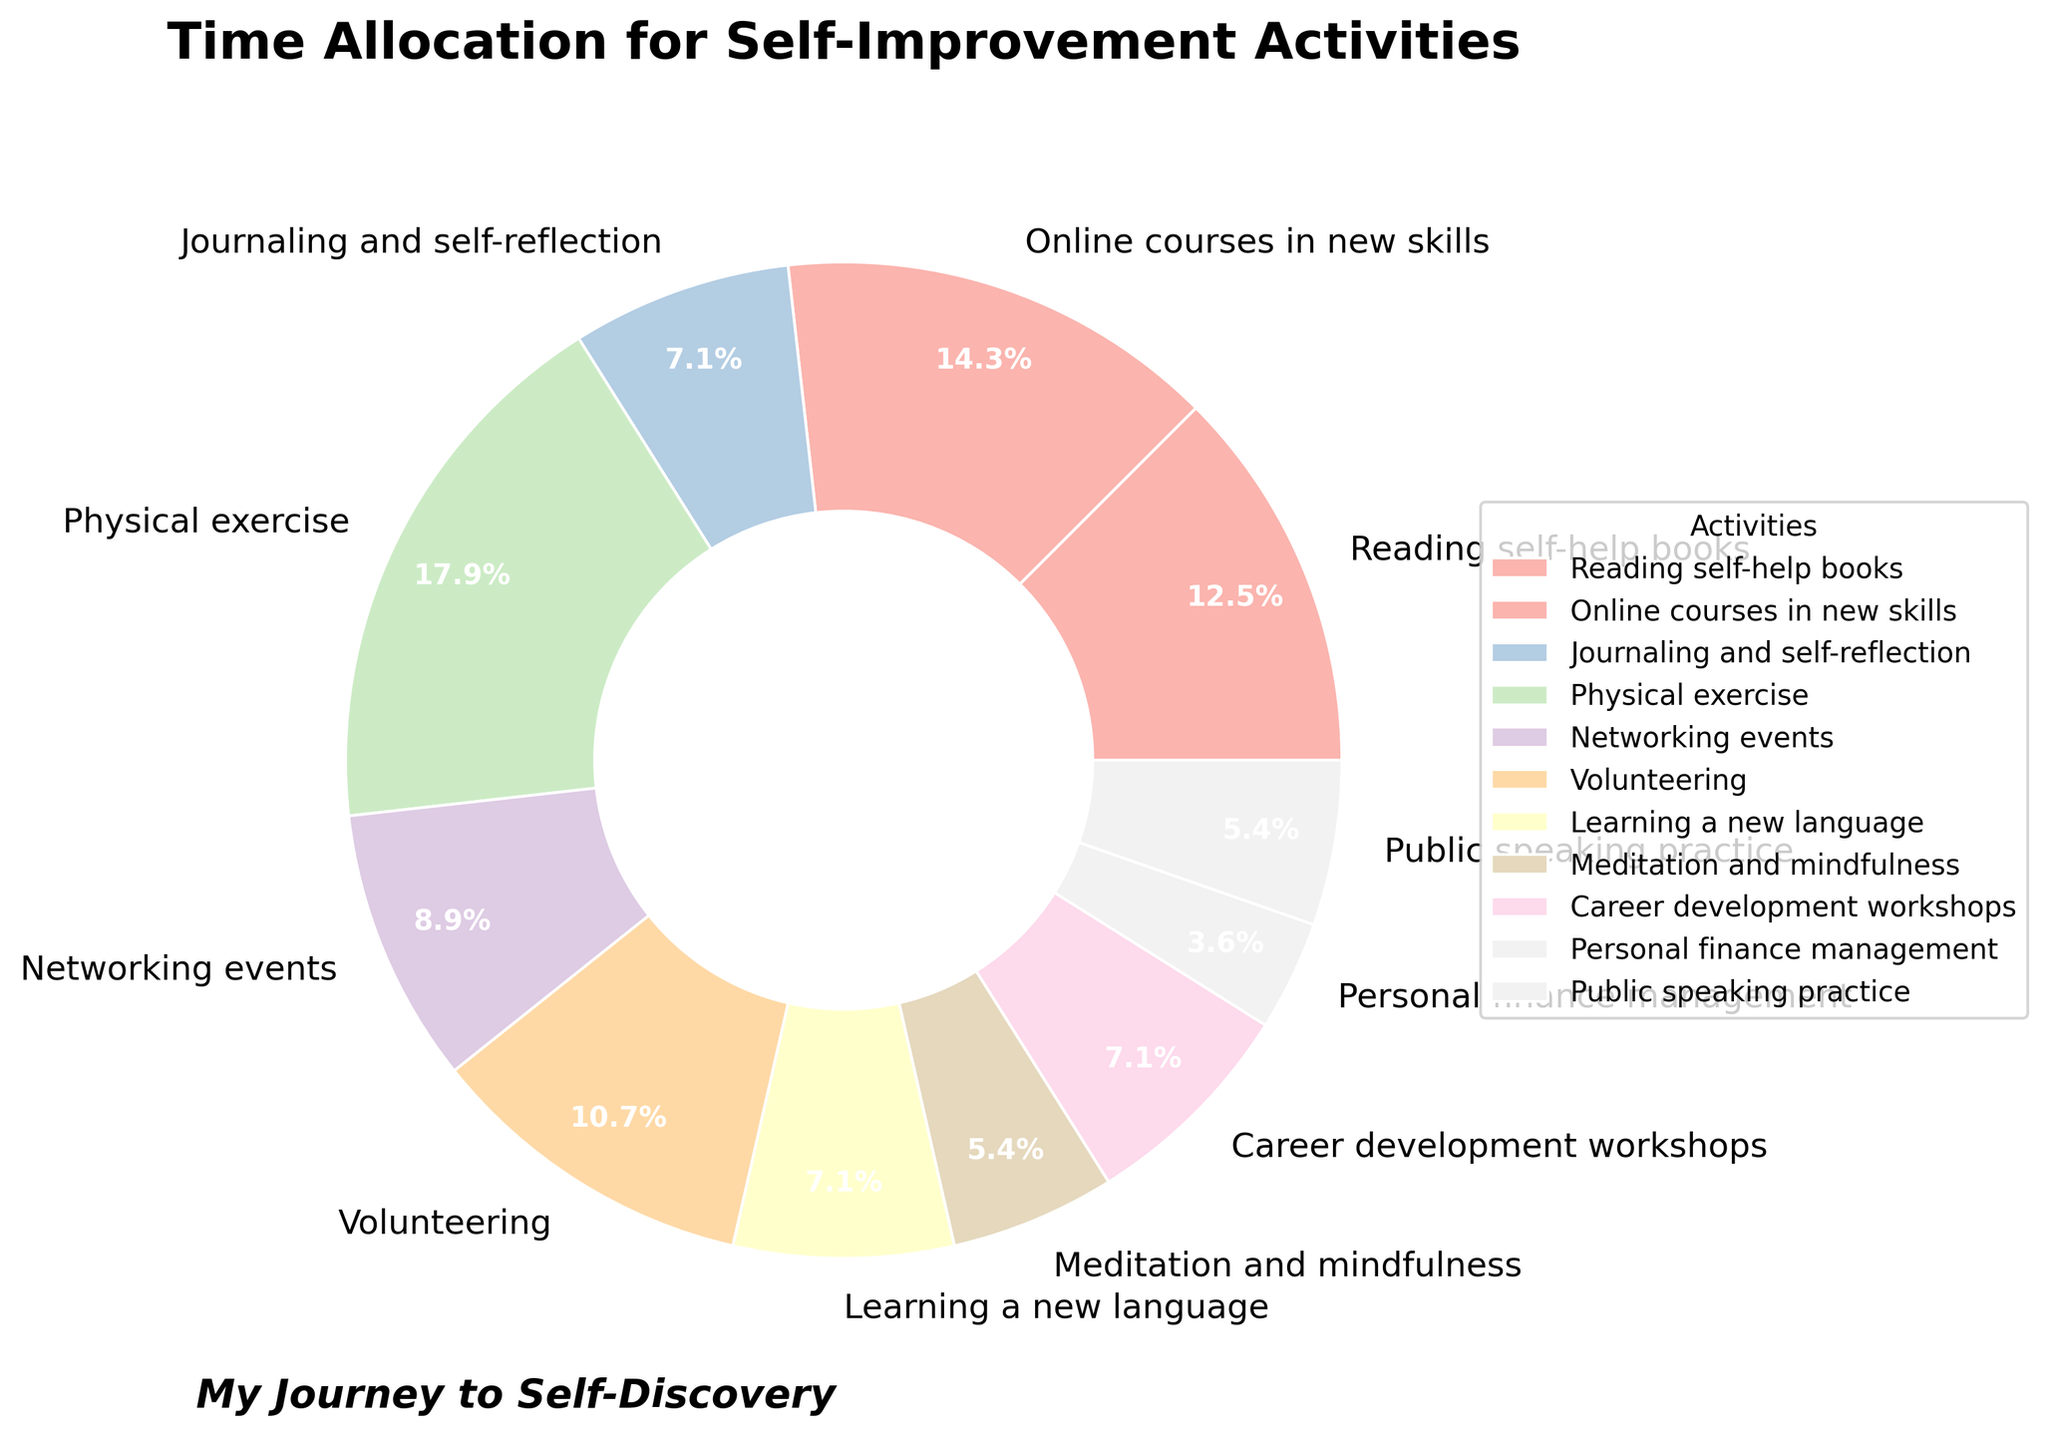What's the total time spent on activities aimed at mental improvements (like reading, journaling, and meditation)? First, identify the activities associated with mental improvements. These are "Reading self-help books" (3.5 hours), "Journaling and self-reflection" (2 hours), and "Meditation and mindfulness" (1.5 hours). Sum these values: 3.5 + 2 + 1.5 = 7.
Answer: 7 hours What's the difference in time allocation between the activity with highest and lowest hours? Identify the activity with the highest hours, which is "Physical exercise" (5 hours), and the activity with the lowest hours, which is "Personal finance management" (1 hour). The difference is 5 - 1 = 4.
Answer: 4 hours Which activity takes up the largest proportion of the time? Look for the activity with the largest wedge in the pie chart. This would be "Physical exercise".
Answer: Physical exercise Are more hours per week spent on networking events or public speaking practice? Compare the hours spent on "Networking events" (2.5 hours) and "Public speaking practice" (1.5 hours). 2.5 is greater than 1.5.
Answer: Networking events How does the time spent on career development workshops compare to that on learning a new language? Compare the hours spent on "Career development workshops" (2 hours) to "Learning a new language" (2 hours). Both are equal.
Answer: Equal Which activities have equal time allocation, and what is that amount? Find the activities with matching hour values. "Journaling and self-reflection" (2 hours), "Learning a new language" (2 hours), and "Career development workshops" (2 hours) all have the same allocation.
Answer: 2 hours How many activities are allocated more than 3 hours per week? Look for activities with more than 3 hours: "Reading self-help books" (3.5 hours), "Online courses in new skills" (4 hours), "Physical exercise" (5 hours), and "Volunteering" (3 hours). There are 4 activities.
Answer: 4 What percentage of time is spent on meditation and mindfulness? The pie chart shows the percent of total hours. For "Meditation and mindfulness," it is 1.5% of the total hours.
Answer: 1.5% What is the average time spent on all activities per week? Sum all the hours: 3.5 + 4 + 2 + 5 + 2.5 + 3 + 2 + 1.5 + 2 + 1 + 1.5 = 28. Divide by the number of activities: 28 / 11 = 2.545 hours per week.
Answer: 2.545 hours Which takes more time, volunteering or learning a new language and journaling combined? Compare "Volunteering" (3 hours) to the sum of "Learning a new language" (2 hours) and "Journaling and self-reflection" (2 hours), which is 2 + 2 = 4. 3 is less than 4.
Answer: Learning a new language and journaling 